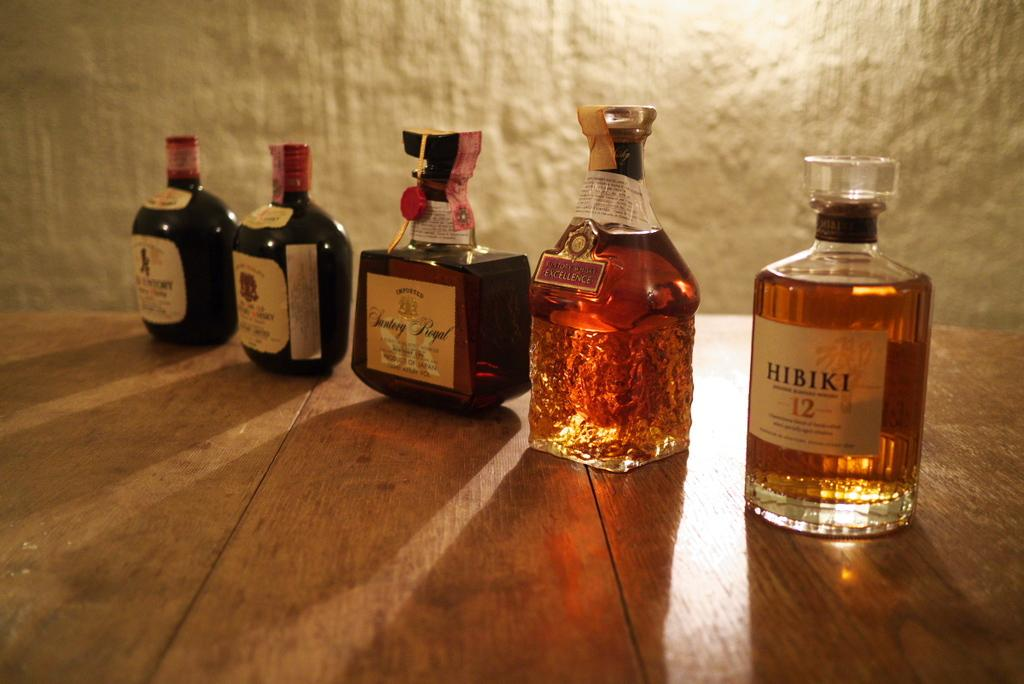<image>
Create a compact narrative representing the image presented. A bottle of Hibiki 12 sits next to other bottles, including a bottle of Santerg Royal, and are displayed on wood planks. 